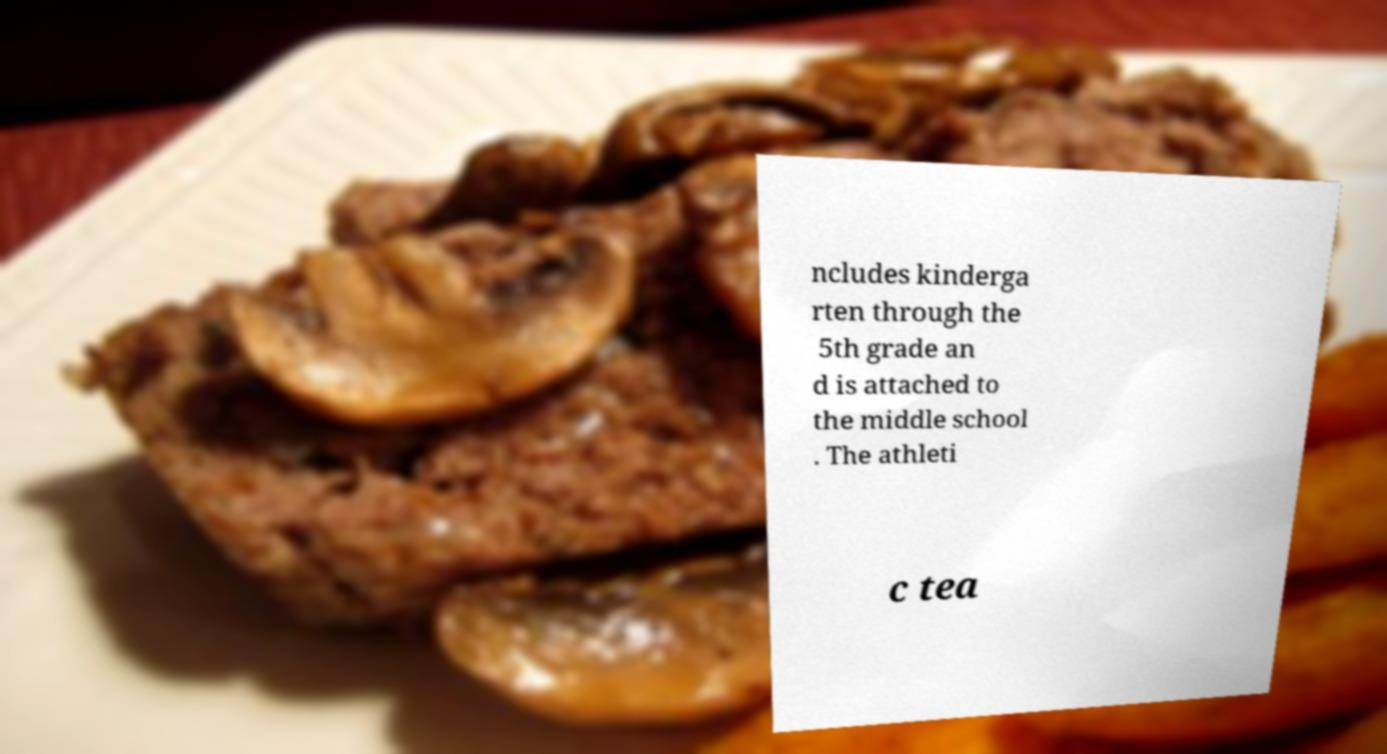For documentation purposes, I need the text within this image transcribed. Could you provide that? ncludes kinderga rten through the 5th grade an d is attached to the middle school . The athleti c tea 